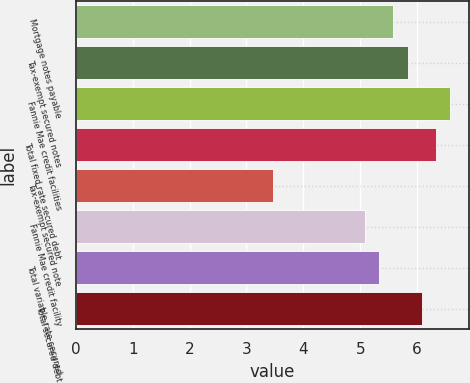<chart> <loc_0><loc_0><loc_500><loc_500><bar_chart><fcel>Mortgage notes payable<fcel>Tax-exempt secured notes<fcel>Fannie Mae credit facilities<fcel>Total fixed rate secured debt<fcel>Tax-exempt secured note<fcel>Fannie Mae credit facility<fcel>Total variable rate secured<fcel>Total secured debt<nl><fcel>5.58<fcel>5.83<fcel>6.58<fcel>6.33<fcel>3.47<fcel>5.08<fcel>5.33<fcel>6.08<nl></chart> 